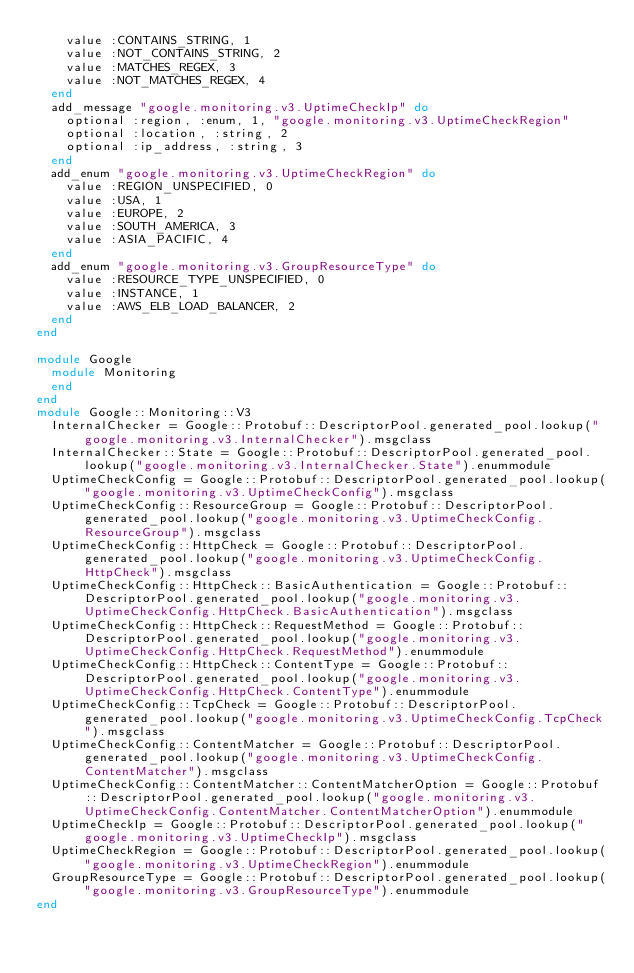Convert code to text. <code><loc_0><loc_0><loc_500><loc_500><_Ruby_>    value :CONTAINS_STRING, 1
    value :NOT_CONTAINS_STRING, 2
    value :MATCHES_REGEX, 3
    value :NOT_MATCHES_REGEX, 4
  end
  add_message "google.monitoring.v3.UptimeCheckIp" do
    optional :region, :enum, 1, "google.monitoring.v3.UptimeCheckRegion"
    optional :location, :string, 2
    optional :ip_address, :string, 3
  end
  add_enum "google.monitoring.v3.UptimeCheckRegion" do
    value :REGION_UNSPECIFIED, 0
    value :USA, 1
    value :EUROPE, 2
    value :SOUTH_AMERICA, 3
    value :ASIA_PACIFIC, 4
  end
  add_enum "google.monitoring.v3.GroupResourceType" do
    value :RESOURCE_TYPE_UNSPECIFIED, 0
    value :INSTANCE, 1
    value :AWS_ELB_LOAD_BALANCER, 2
  end
end

module Google
  module Monitoring
  end
end
module Google::Monitoring::V3
  InternalChecker = Google::Protobuf::DescriptorPool.generated_pool.lookup("google.monitoring.v3.InternalChecker").msgclass
  InternalChecker::State = Google::Protobuf::DescriptorPool.generated_pool.lookup("google.monitoring.v3.InternalChecker.State").enummodule
  UptimeCheckConfig = Google::Protobuf::DescriptorPool.generated_pool.lookup("google.monitoring.v3.UptimeCheckConfig").msgclass
  UptimeCheckConfig::ResourceGroup = Google::Protobuf::DescriptorPool.generated_pool.lookup("google.monitoring.v3.UptimeCheckConfig.ResourceGroup").msgclass
  UptimeCheckConfig::HttpCheck = Google::Protobuf::DescriptorPool.generated_pool.lookup("google.monitoring.v3.UptimeCheckConfig.HttpCheck").msgclass
  UptimeCheckConfig::HttpCheck::BasicAuthentication = Google::Protobuf::DescriptorPool.generated_pool.lookup("google.monitoring.v3.UptimeCheckConfig.HttpCheck.BasicAuthentication").msgclass
  UptimeCheckConfig::HttpCheck::RequestMethod = Google::Protobuf::DescriptorPool.generated_pool.lookup("google.monitoring.v3.UptimeCheckConfig.HttpCheck.RequestMethod").enummodule
  UptimeCheckConfig::HttpCheck::ContentType = Google::Protobuf::DescriptorPool.generated_pool.lookup("google.monitoring.v3.UptimeCheckConfig.HttpCheck.ContentType").enummodule
  UptimeCheckConfig::TcpCheck = Google::Protobuf::DescriptorPool.generated_pool.lookup("google.monitoring.v3.UptimeCheckConfig.TcpCheck").msgclass
  UptimeCheckConfig::ContentMatcher = Google::Protobuf::DescriptorPool.generated_pool.lookup("google.monitoring.v3.UptimeCheckConfig.ContentMatcher").msgclass
  UptimeCheckConfig::ContentMatcher::ContentMatcherOption = Google::Protobuf::DescriptorPool.generated_pool.lookup("google.monitoring.v3.UptimeCheckConfig.ContentMatcher.ContentMatcherOption").enummodule
  UptimeCheckIp = Google::Protobuf::DescriptorPool.generated_pool.lookup("google.monitoring.v3.UptimeCheckIp").msgclass
  UptimeCheckRegion = Google::Protobuf::DescriptorPool.generated_pool.lookup("google.monitoring.v3.UptimeCheckRegion").enummodule
  GroupResourceType = Google::Protobuf::DescriptorPool.generated_pool.lookup("google.monitoring.v3.GroupResourceType").enummodule
end
</code> 